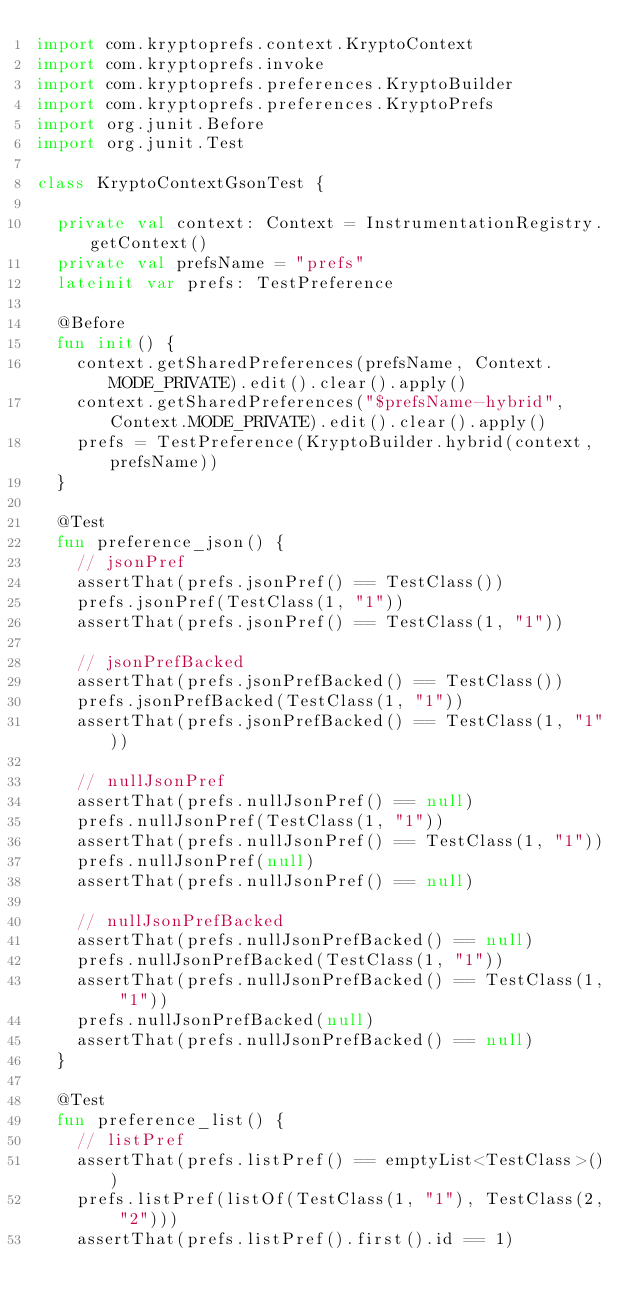<code> <loc_0><loc_0><loc_500><loc_500><_Kotlin_>import com.kryptoprefs.context.KryptoContext
import com.kryptoprefs.invoke
import com.kryptoprefs.preferences.KryptoBuilder
import com.kryptoprefs.preferences.KryptoPrefs
import org.junit.Before
import org.junit.Test

class KryptoContextGsonTest {

	private val context: Context = InstrumentationRegistry.getContext()
	private val prefsName = "prefs"
	lateinit var prefs: TestPreference

	@Before
	fun init() {
		context.getSharedPreferences(prefsName, Context.MODE_PRIVATE).edit().clear().apply()
		context.getSharedPreferences("$prefsName-hybrid", Context.MODE_PRIVATE).edit().clear().apply()
		prefs = TestPreference(KryptoBuilder.hybrid(context, prefsName))
	}

	@Test
	fun preference_json() {
		// jsonPref
		assertThat(prefs.jsonPref() == TestClass())
		prefs.jsonPref(TestClass(1, "1"))
		assertThat(prefs.jsonPref() == TestClass(1, "1"))

		// jsonPrefBacked
		assertThat(prefs.jsonPrefBacked() == TestClass())
		prefs.jsonPrefBacked(TestClass(1, "1"))
		assertThat(prefs.jsonPrefBacked() == TestClass(1, "1"))

		// nullJsonPref
		assertThat(prefs.nullJsonPref() == null)
		prefs.nullJsonPref(TestClass(1, "1"))
		assertThat(prefs.nullJsonPref() == TestClass(1, "1"))
		prefs.nullJsonPref(null)
		assertThat(prefs.nullJsonPref() == null)

		// nullJsonPrefBacked
		assertThat(prefs.nullJsonPrefBacked() == null)
		prefs.nullJsonPrefBacked(TestClass(1, "1"))
		assertThat(prefs.nullJsonPrefBacked() == TestClass(1, "1"))
		prefs.nullJsonPrefBacked(null)
		assertThat(prefs.nullJsonPrefBacked() == null)
	}

	@Test
	fun preference_list() {
		// listPref
		assertThat(prefs.listPref() == emptyList<TestClass>())
		prefs.listPref(listOf(TestClass(1, "1"), TestClass(2, "2")))
		assertThat(prefs.listPref().first().id == 1)</code> 